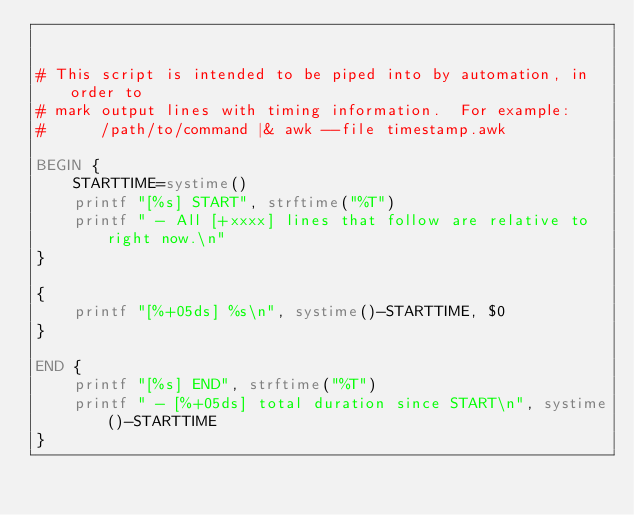<code> <loc_0><loc_0><loc_500><loc_500><_Awk_>

# This script is intended to be piped into by automation, in order to
# mark output lines with timing information.  For example:
#      /path/to/command |& awk --file timestamp.awk

BEGIN {
    STARTTIME=systime()
    printf "[%s] START", strftime("%T")
    printf " - All [+xxxx] lines that follow are relative to right now.\n"
}

{
    printf "[%+05ds] %s\n", systime()-STARTTIME, $0
}

END {
    printf "[%s] END", strftime("%T")
    printf " - [%+05ds] total duration since START\n", systime()-STARTTIME
}
</code> 